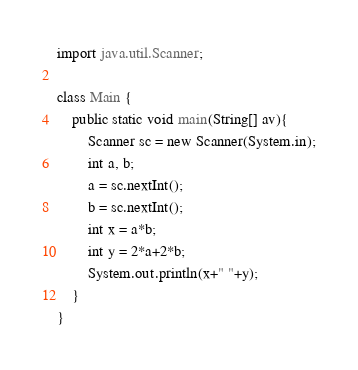Convert code to text. <code><loc_0><loc_0><loc_500><loc_500><_Java_>import java.util.Scanner;

class Main {
    public static void main(String[] av){
    	Scanner sc = new Scanner(System.in);
    	int a, b;
    	a = sc.nextInt();
    	b = sc.nextInt();
    	int x = a*b;
    	int y = 2*a+2*b;
    	System.out.println(x+" "+y);
    }
}

</code> 